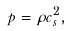<formula> <loc_0><loc_0><loc_500><loc_500>p = \rho c _ { s } ^ { 2 } ,</formula> 